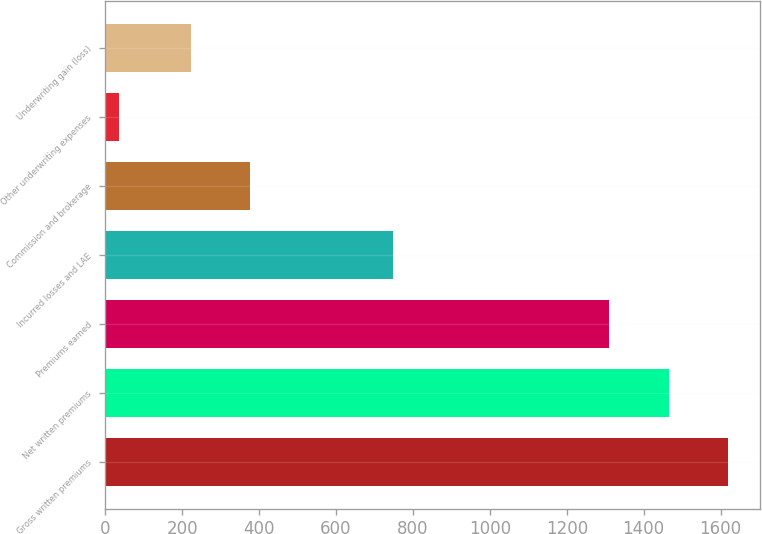<chart> <loc_0><loc_0><loc_500><loc_500><bar_chart><fcel>Gross written premiums<fcel>Net written premiums<fcel>Premiums earned<fcel>Incurred losses and LAE<fcel>Commission and brokerage<fcel>Other underwriting expenses<fcel>Underwriting gain (loss)<nl><fcel>1620.46<fcel>1465.68<fcel>1310.9<fcel>748.2<fcel>376.68<fcel>34.6<fcel>221.9<nl></chart> 